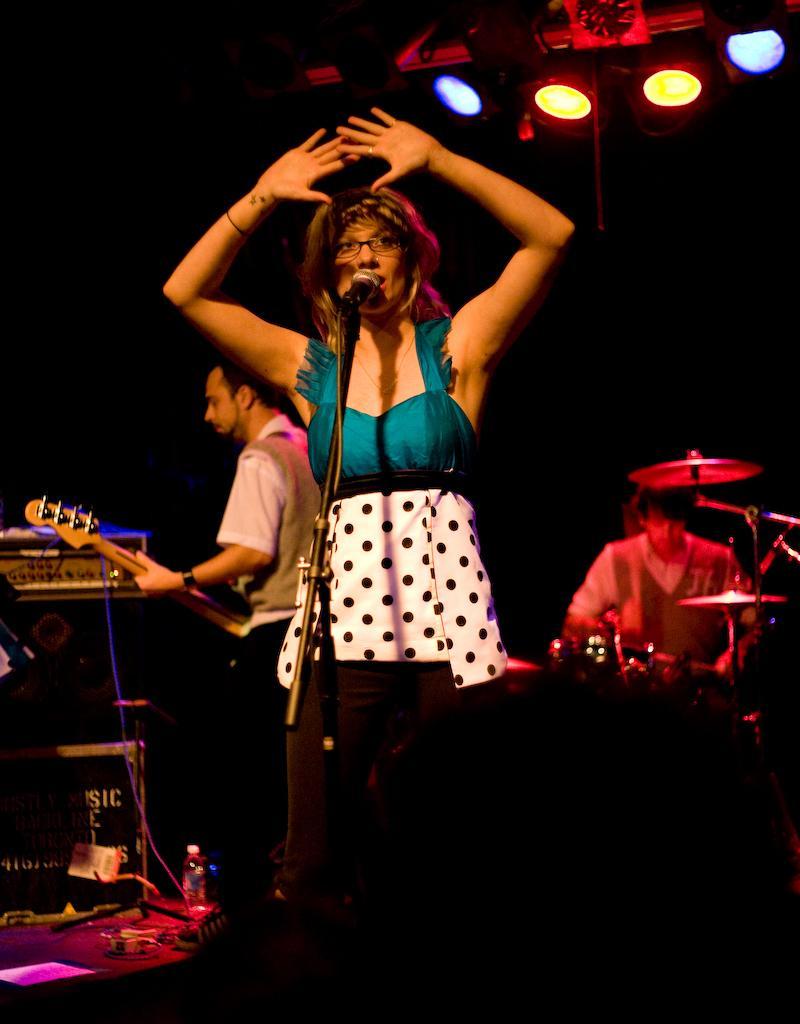In one or two sentences, can you explain what this image depicts? In the picture we can see a woman talking in a micro phone, in the background we can see person holding a guitar and person playing a musical instruments and there are lights. 